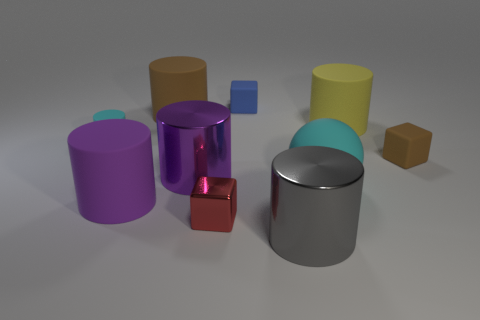There is a cyan rubber thing that is to the left of the metal cylinder behind the tiny cube that is in front of the tiny brown rubber cube; what is its shape?
Provide a short and direct response. Cylinder. What color is the large cylinder that is in front of the tiny shiny block?
Offer a very short reply. Gray. How many objects are objects that are in front of the tiny blue rubber cube or cubes left of the blue block?
Offer a terse response. 9. How many blue objects are the same shape as the small brown rubber object?
Provide a short and direct response. 1. What is the color of the matte sphere that is the same size as the purple rubber object?
Offer a very short reply. Cyan. The small block in front of the small thing right of the shiny thing that is to the right of the metal cube is what color?
Ensure brevity in your answer.  Red. Do the blue matte thing and the purple shiny cylinder that is left of the gray metallic cylinder have the same size?
Ensure brevity in your answer.  No. What number of things are yellow cylinders or tiny brown things?
Offer a very short reply. 2. Are there any big things that have the same material as the large yellow cylinder?
Keep it short and to the point. Yes. There is a object that is the same color as the tiny cylinder; what size is it?
Your answer should be very brief. Large. 